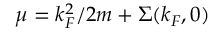<formula> <loc_0><loc_0><loc_500><loc_500>\mu = k _ { F } ^ { 2 } / 2 m + \Sigma ( k _ { F } , 0 )</formula> 